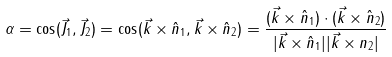Convert formula to latex. <formula><loc_0><loc_0><loc_500><loc_500>\alpha = \cos ( \vec { J } _ { 1 } , \vec { J } _ { 2 } ) = \cos ( \vec { k } \times \hat { n } _ { 1 } , \vec { k } \times \hat { n } _ { 2 } ) = \frac { ( \vec { k } \times \hat { n } _ { 1 } ) \cdot ( \vec { k } \times \hat { n } _ { 2 } ) } { | \vec { k } \times \hat { n } _ { 1 } | | \vec { k } \times n _ { 2 } | }</formula> 